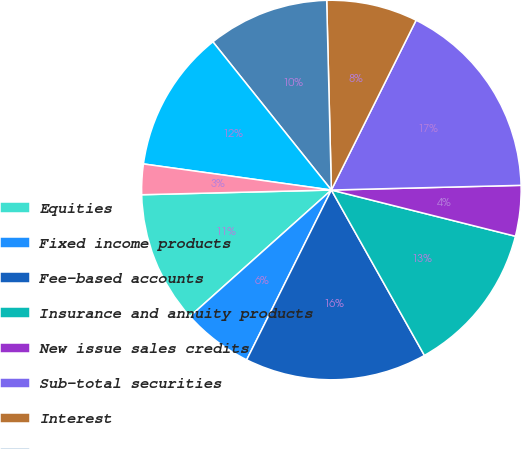Convert chart to OTSL. <chart><loc_0><loc_0><loc_500><loc_500><pie_chart><fcel>Equities<fcel>Fixed income products<fcel>Fee-based accounts<fcel>Insurance and annuity products<fcel>New issue sales credits<fcel>Sub-total securities<fcel>Interest<fcel>Client account and service<fcel>Mutual fund and annuity<fcel>Client transaction fees<nl><fcel>11.21%<fcel>6.03%<fcel>15.52%<fcel>12.93%<fcel>4.31%<fcel>17.24%<fcel>7.76%<fcel>10.34%<fcel>12.07%<fcel>2.59%<nl></chart> 